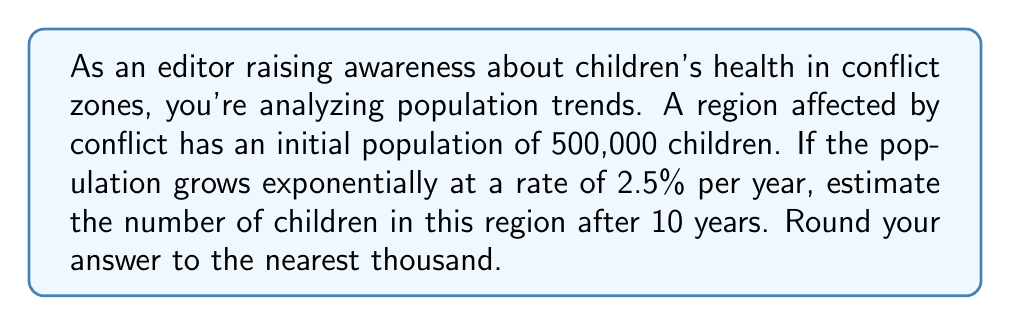Can you solve this math problem? To solve this problem, we'll use the exponential growth model:

$$P(t) = P_0 \cdot e^{rt}$$

Where:
$P(t)$ is the population at time $t$
$P_0$ is the initial population
$r$ is the growth rate
$t$ is the time in years

Given:
$P_0 = 500,000$
$r = 2.5\% = 0.025$
$t = 10$ years

Step 1: Substitute the values into the exponential growth formula:
$$P(10) = 500,000 \cdot e^{0.025 \cdot 10}$$

Step 2: Simplify the exponent:
$$P(10) = 500,000 \cdot e^{0.25}$$

Step 3: Calculate $e^{0.25}$ using a calculator:
$$e^{0.25} \approx 1.2840$$

Step 4: Multiply:
$$P(10) = 500,000 \cdot 1.2840 \approx 642,000$$

Step 5: Round to the nearest thousand:
$$P(10) \approx 642,000$$

This result indicates that after 10 years, the estimated population of children in the conflict zone will be approximately 642,000.
Answer: 642,000 children 